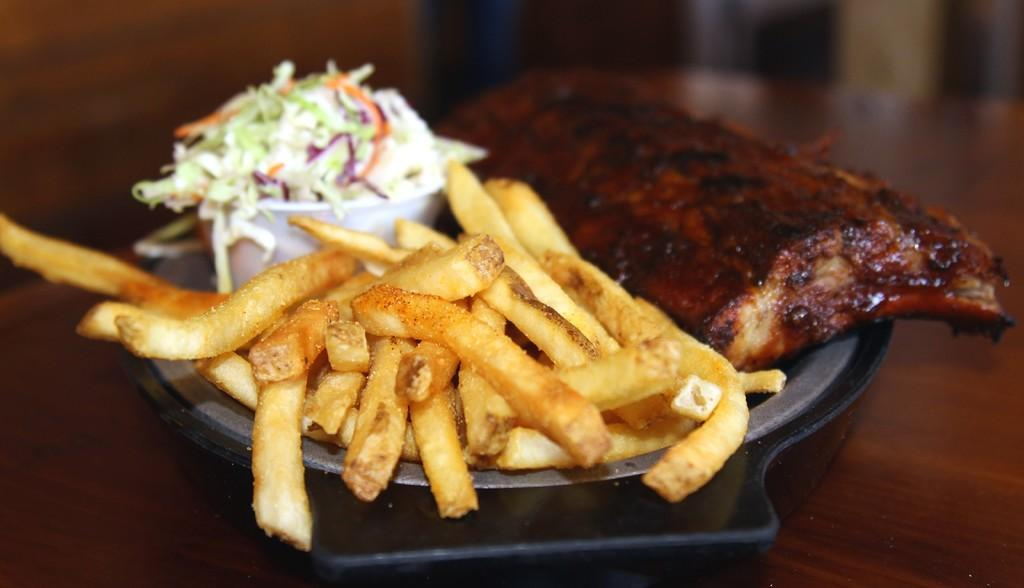What type of food can be seen in the image? The image contains french fries, flesh, and salad. How are the food items arranged in the image? The food items are kept in a bowl. What type of surface is the bowl placed on in the image? There is a wooden table in the image. What type of bird can be seen perched on the edge of the bowl in the image? There is no bird present in the image, so it cannot be determined what type of bird might be perched on the edge of the bowl. 